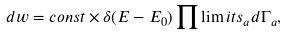<formula> <loc_0><loc_0><loc_500><loc_500>d w = c o n s t \times \delta ( E - E _ { 0 } ) \prod \lim i t s _ { a } d \Gamma _ { a } ,</formula> 